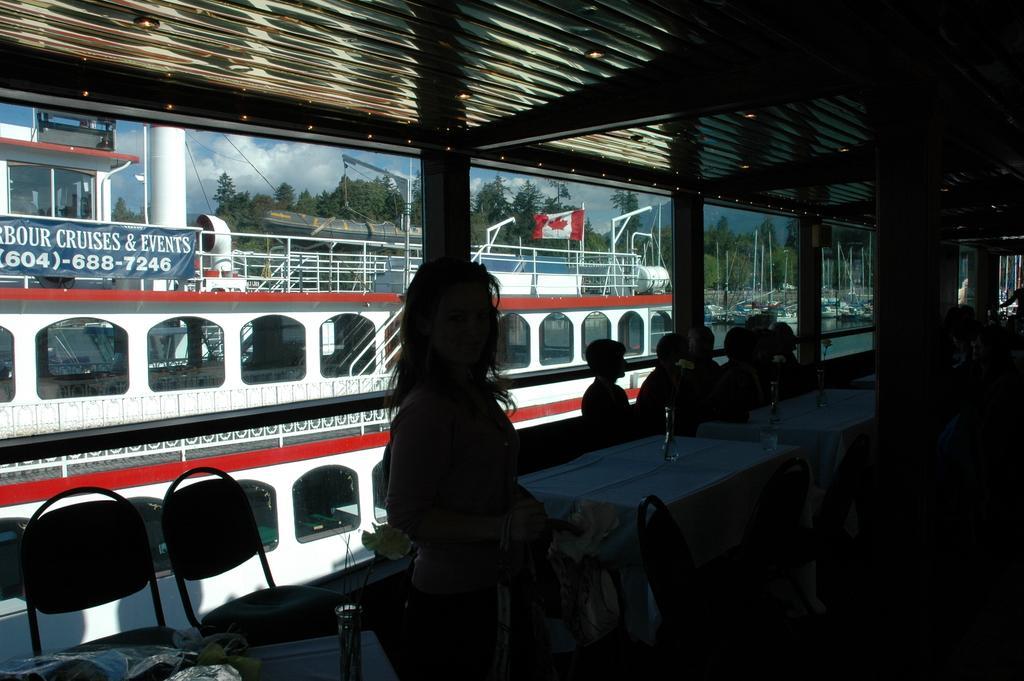Can you describe this image briefly? In this image I can see few ships,water,chairs,tables and few people are sitting on chairs. Back I can see few trees,flag and banner. The sky is in white and blue color. 